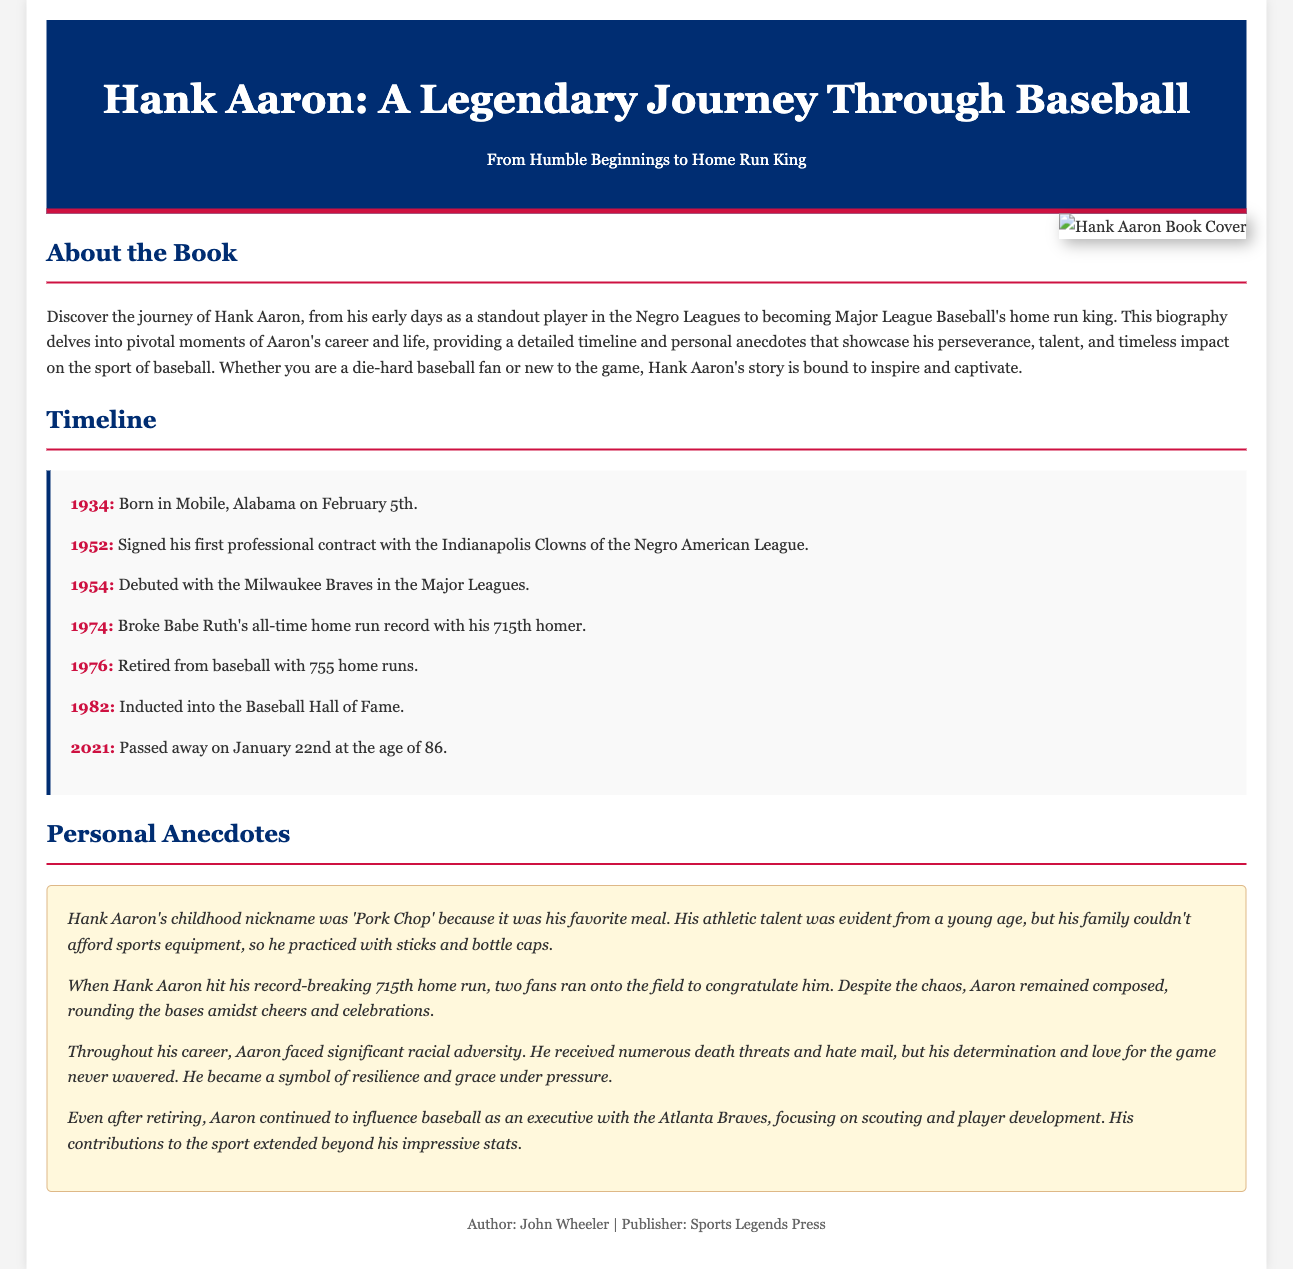What year was Hank Aaron born? The document states Hank Aaron was born in 1934.
Answer: 1934 What was Hank Aaron's childhood nickname? The document mentions his childhood nickname was 'Pork Chop'.
Answer: Pork Chop In what year did Hank Aaron break Babe Ruth's home run record? According to the document, he broke the record in 1974.
Answer: 1974 How many home runs did Hank Aaron retire with? The document indicates he retired with 755 home runs.
Answer: 755 What is the title of the book? The document provides the title as "Hank Aaron: A Legendary Journey Through Baseball".
Answer: Hank Aaron: A Legendary Journey Through Baseball What significant event happened in 1982 regarding Hank Aaron? The document states that in 1982, Hank Aaron was inducted into the Baseball Hall of Fame.
Answer: Inducted into the Baseball Hall of Fame How did Hank Aaron respond to the chaos after his record-breaking home run? The anecdotes mention that he remained composed amidst the chaos.
Answer: Remained composed What was a major focus for Hank Aaron after retirement? The document mentions he focused on scouting and player development with the Atlanta Braves.
Answer: Scouting and player development 